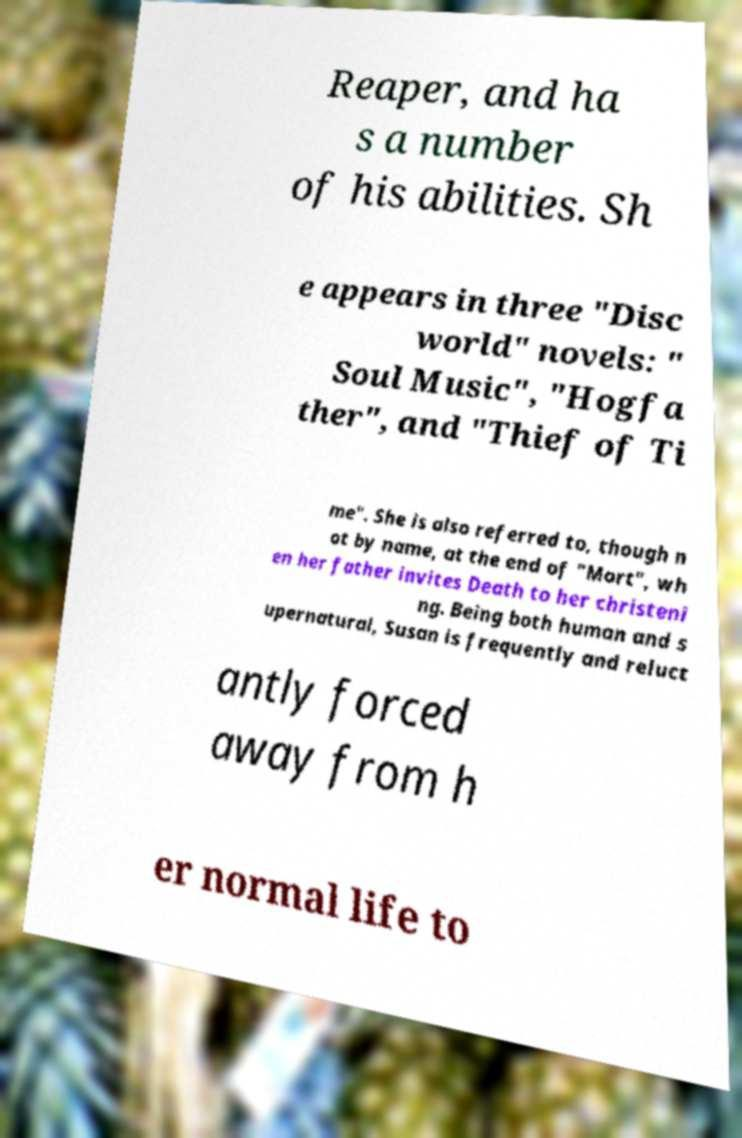What messages or text are displayed in this image? I need them in a readable, typed format. Reaper, and ha s a number of his abilities. Sh e appears in three "Disc world" novels: " Soul Music", "Hogfa ther", and "Thief of Ti me". She is also referred to, though n ot by name, at the end of "Mort", wh en her father invites Death to her christeni ng. Being both human and s upernatural, Susan is frequently and reluct antly forced away from h er normal life to 